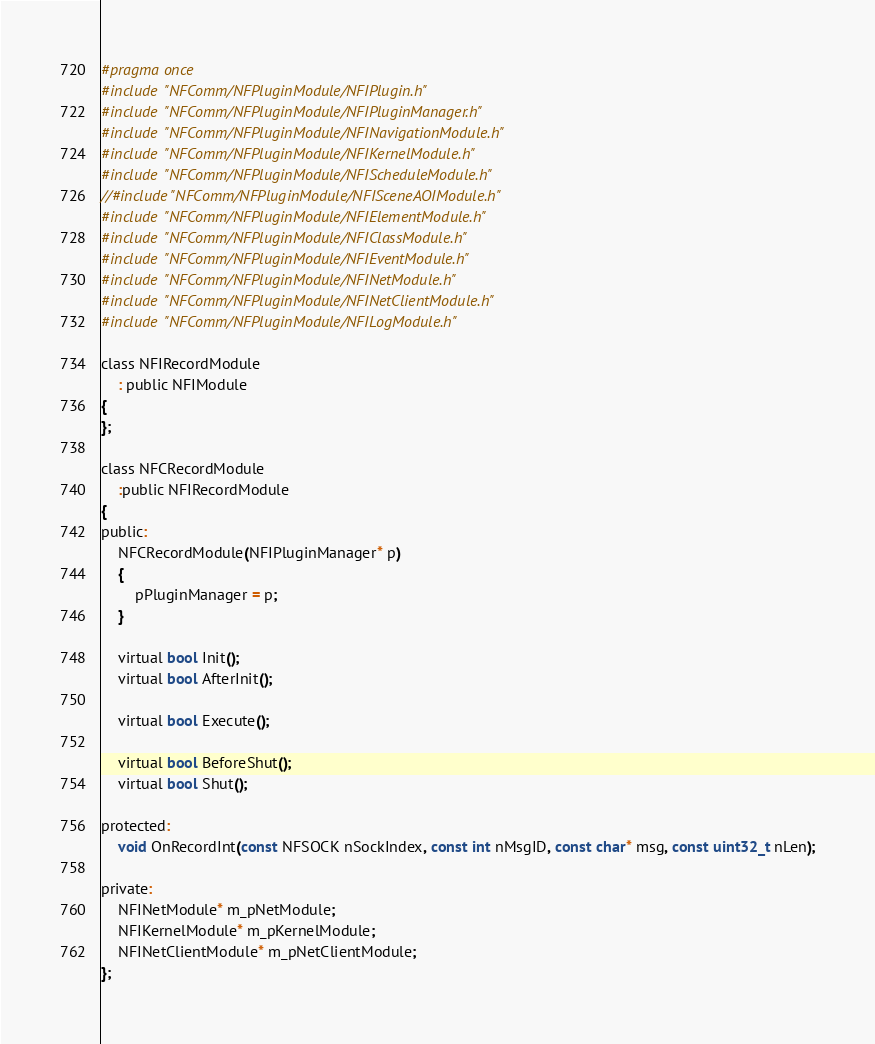Convert code to text. <code><loc_0><loc_0><loc_500><loc_500><_C_>#pragma once
#include "NFComm/NFPluginModule/NFIPlugin.h"
#include "NFComm/NFPluginModule/NFIPluginManager.h"
#include "NFComm/NFPluginModule/NFINavigationModule.h"
#include "NFComm/NFPluginModule/NFIKernelModule.h"
#include "NFComm/NFPluginModule/NFIScheduleModule.h"
//#include "NFComm/NFPluginModule/NFISceneAOIModule.h"
#include "NFComm/NFPluginModule/NFIElementModule.h"
#include "NFComm/NFPluginModule/NFIClassModule.h"
#include "NFComm/NFPluginModule/NFIEventModule.h"
#include "NFComm/NFPluginModule/NFINetModule.h"
#include "NFComm/NFPluginModule/NFINetClientModule.h"
#include "NFComm/NFPluginModule/NFILogModule.h"

class NFIRecordModule
	: public NFIModule
{
};

class NFCRecordModule
	:public NFIRecordModule
{
public:
	NFCRecordModule(NFIPluginManager* p)
	{
		pPluginManager = p;
	}

	virtual bool Init();
	virtual bool AfterInit();

	virtual bool Execute();

	virtual bool BeforeShut();
	virtual bool Shut();

protected:
	void OnRecordInt(const NFSOCK nSockIndex, const int nMsgID, const char* msg, const uint32_t nLen);

private:
	NFINetModule* m_pNetModule;
	NFIKernelModule* m_pKernelModule;
	NFINetClientModule* m_pNetClientModule;
};
</code> 